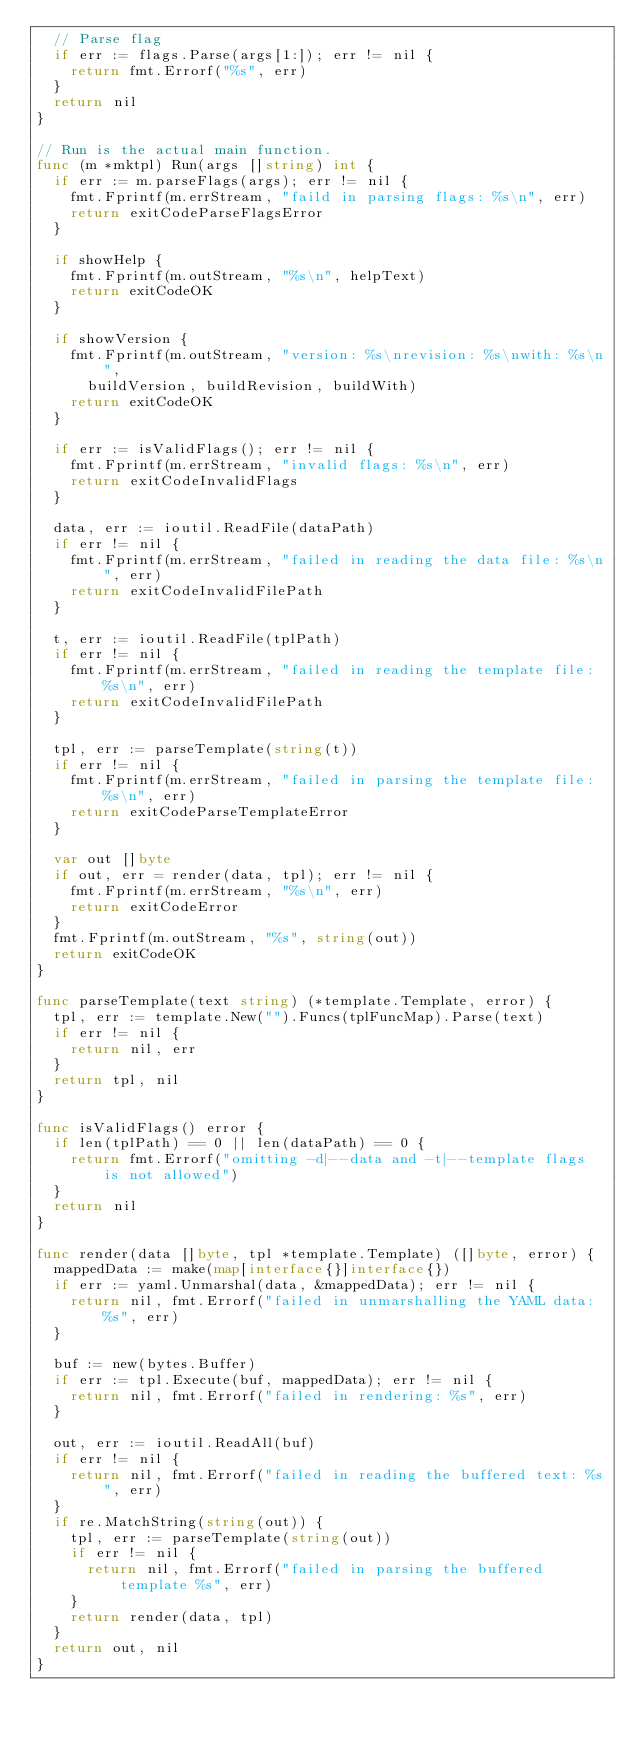Convert code to text. <code><loc_0><loc_0><loc_500><loc_500><_Go_>	// Parse flag
	if err := flags.Parse(args[1:]); err != nil {
		return fmt.Errorf("%s", err)
	}
	return nil
}

// Run is the actual main function.
func (m *mktpl) Run(args []string) int {
	if err := m.parseFlags(args); err != nil {
		fmt.Fprintf(m.errStream, "faild in parsing flags: %s\n", err)
		return exitCodeParseFlagsError
	}

	if showHelp {
		fmt.Fprintf(m.outStream, "%s\n", helpText)
		return exitCodeOK
	}

	if showVersion {
		fmt.Fprintf(m.outStream, "version: %s\nrevision: %s\nwith: %s\n",
			buildVersion, buildRevision, buildWith)
		return exitCodeOK
	}

	if err := isValidFlags(); err != nil {
		fmt.Fprintf(m.errStream, "invalid flags: %s\n", err)
		return exitCodeInvalidFlags
	}

	data, err := ioutil.ReadFile(dataPath)
	if err != nil {
		fmt.Fprintf(m.errStream, "failed in reading the data file: %s\n", err)
		return exitCodeInvalidFilePath
	}

	t, err := ioutil.ReadFile(tplPath)
	if err != nil {
		fmt.Fprintf(m.errStream, "failed in reading the template file: %s\n", err)
		return exitCodeInvalidFilePath
	}

	tpl, err := parseTemplate(string(t))
	if err != nil {
		fmt.Fprintf(m.errStream, "failed in parsing the template file: %s\n", err)
		return exitCodeParseTemplateError
	}

	var out []byte
	if out, err = render(data, tpl); err != nil {
		fmt.Fprintf(m.errStream, "%s\n", err)
		return exitCodeError
	}
	fmt.Fprintf(m.outStream, "%s", string(out))
	return exitCodeOK
}

func parseTemplate(text string) (*template.Template, error) {
	tpl, err := template.New("").Funcs(tplFuncMap).Parse(text)
	if err != nil {
		return nil, err
	}
	return tpl, nil
}

func isValidFlags() error {
	if len(tplPath) == 0 || len(dataPath) == 0 {
		return fmt.Errorf("omitting -d|--data and -t|--template flags is not allowed")
	}
	return nil
}

func render(data []byte, tpl *template.Template) ([]byte, error) {
	mappedData := make(map[interface{}]interface{})
	if err := yaml.Unmarshal(data, &mappedData); err != nil {
		return nil, fmt.Errorf("failed in unmarshalling the YAML data: %s", err)
	}

	buf := new(bytes.Buffer)
	if err := tpl.Execute(buf, mappedData); err != nil {
		return nil, fmt.Errorf("failed in rendering: %s", err)
	}

	out, err := ioutil.ReadAll(buf)
	if err != nil {
		return nil, fmt.Errorf("failed in reading the buffered text: %s", err)
	}
	if re.MatchString(string(out)) {
		tpl, err := parseTemplate(string(out))
		if err != nil {
			return nil, fmt.Errorf("failed in parsing the buffered template %s", err)
		}
		return render(data, tpl)
	}
	return out, nil
}
</code> 